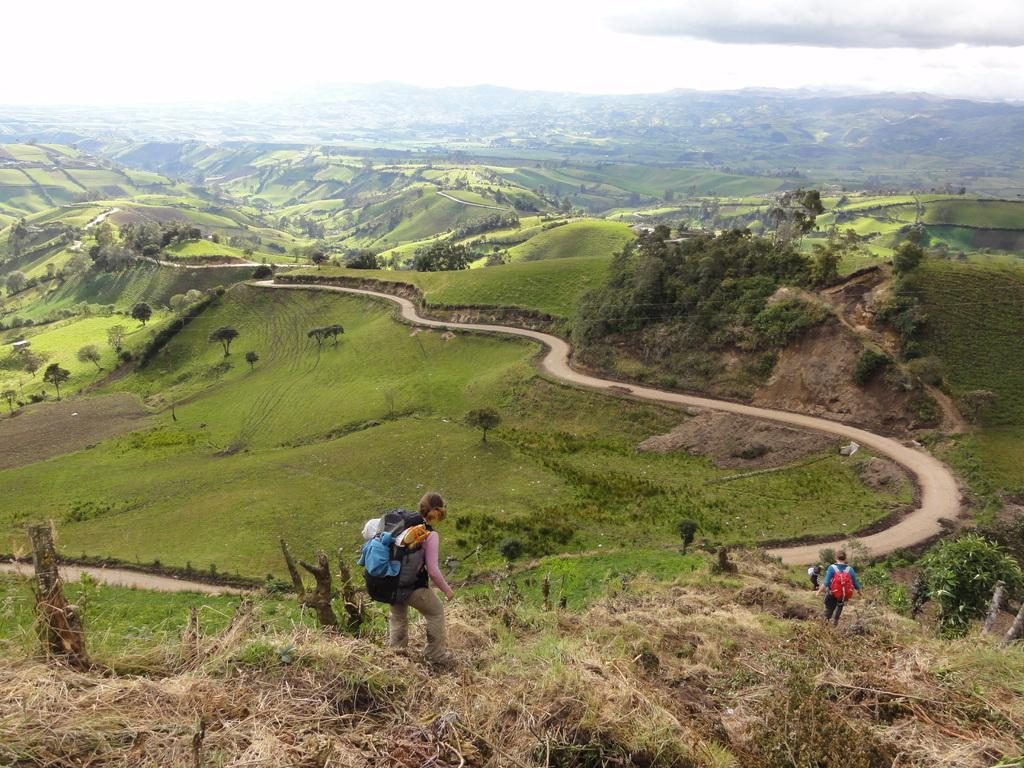What are the people in the image doing? The people in the image are walking. What can be seen in the background of the image? There are trees in the background of the image. What is visible in the sky in the image? There are clouds visible in the sky. What type of stocking is hanging from the tree in the image? There is no stocking hanging from the tree in the image; only trees are visible in the background. 